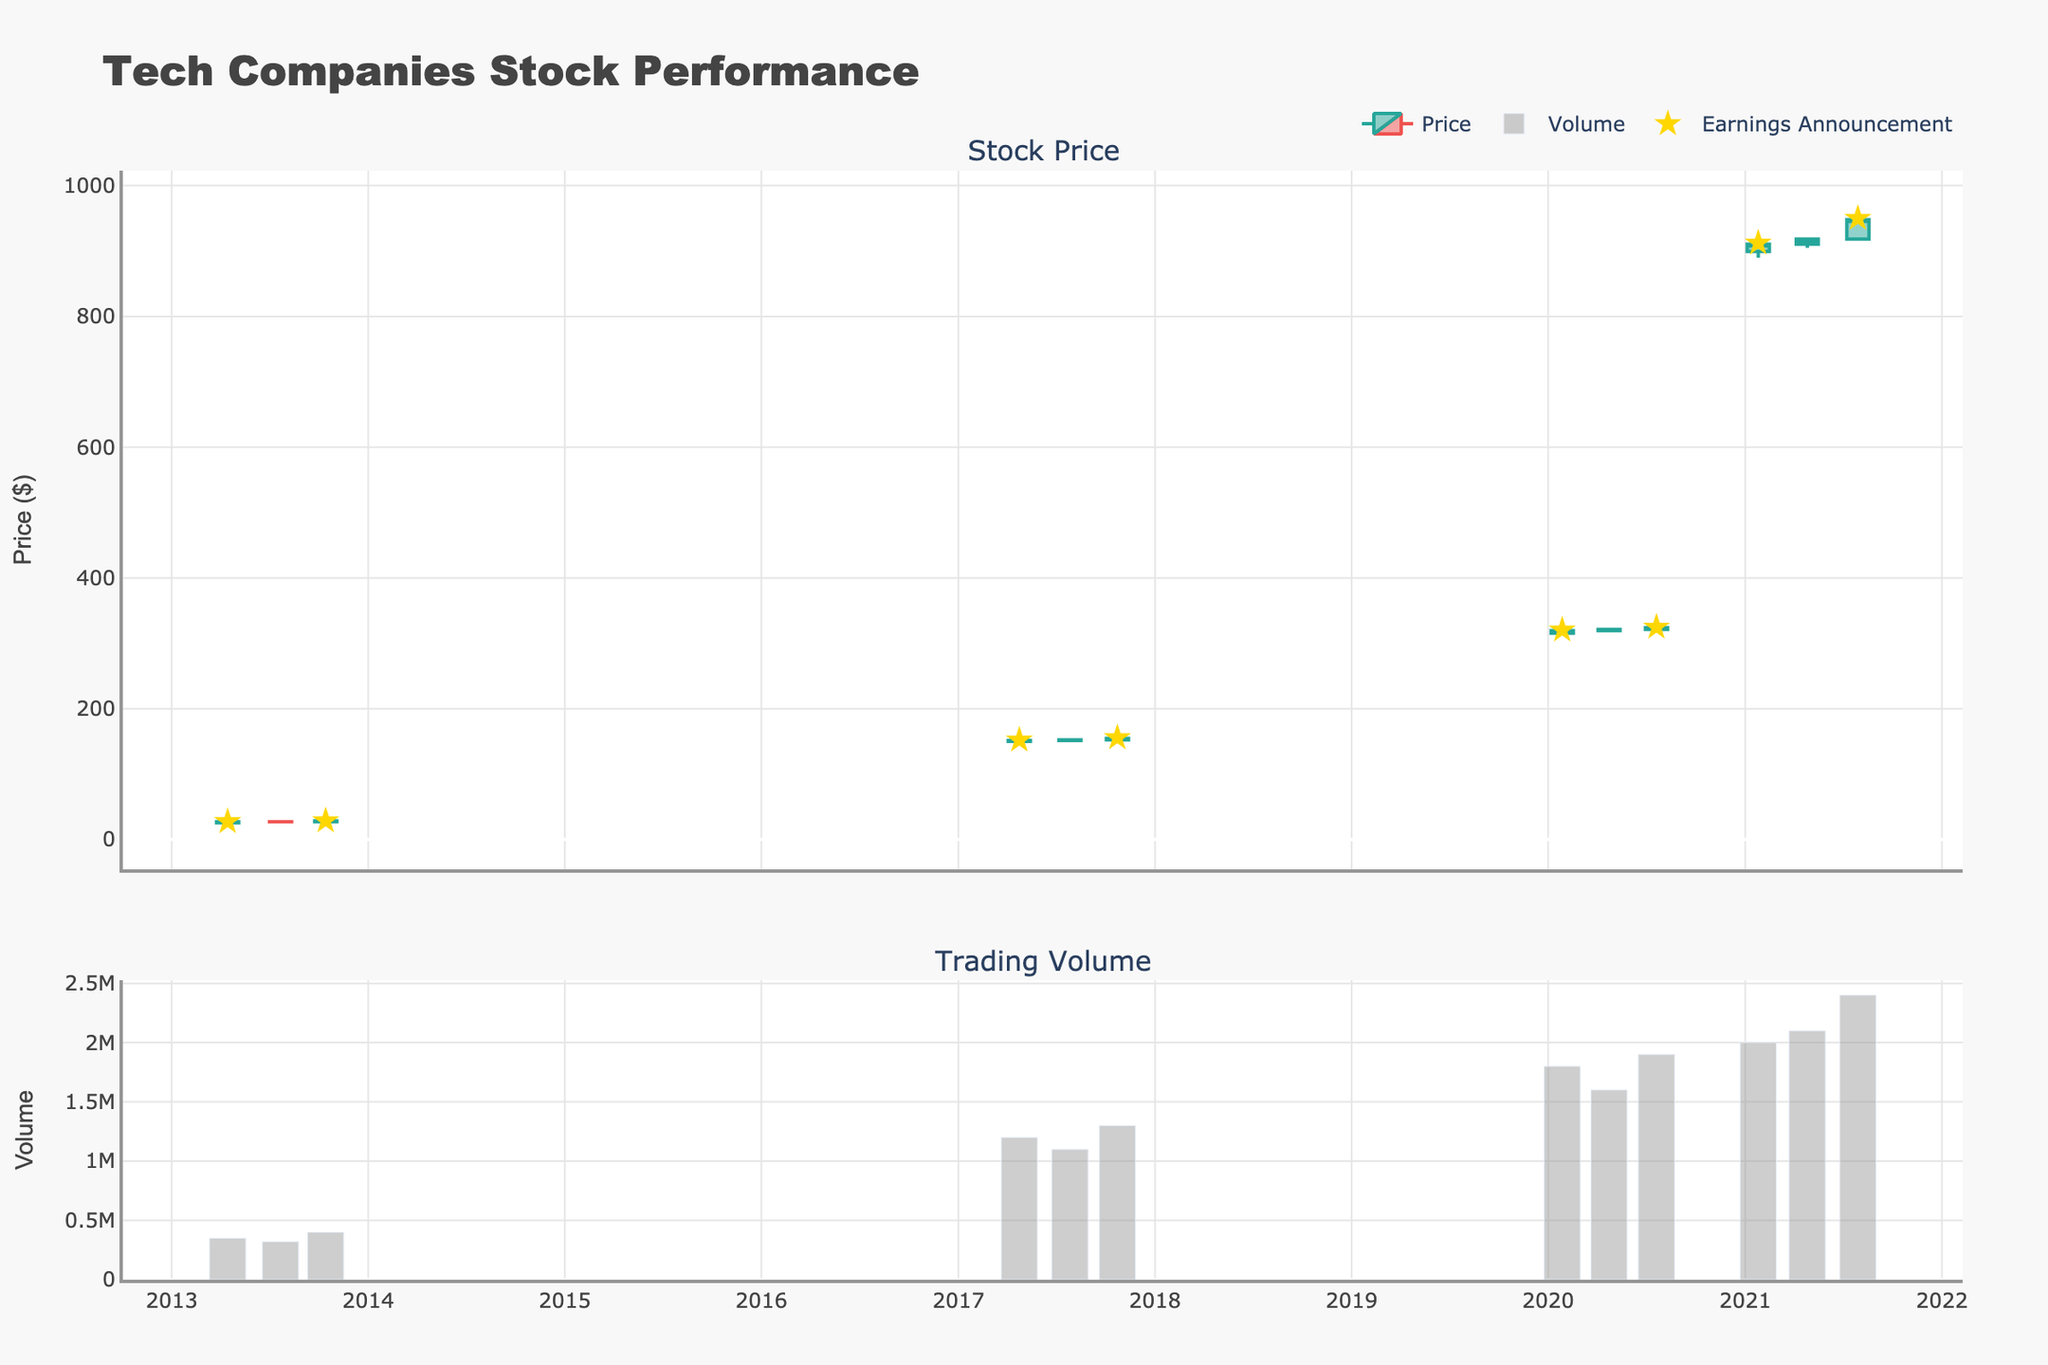What is the title of the plot? The title of the plot can be found at the top center of the figure. It typically summarizes the contents of the graph.
Answer: Tech Companies Stock Performance How many days have an earnings announcement? To find this, count the markers representing earnings announcements (stars) along the date axis in the stock price section of the plot.
Answer: 7 Which company's stock had the highest trading volume on a nonspecific earnings announcement day? Identify the bars in the Volume chart that do not correspond to earnings announcement markers (stars) and find the one with the greatest value.
Answer: Amazon What is the price range of Google's stock on October 23, 2017? Locate the candlestick for the date October 23, 2017, then check the High and Low prices listed for that day.
Answer: 151.20 to 155.65 Did Apple’s stock price increase or decrease after the earnings announcement on April 15, 2013? Look at the candlestick for April 15, 2013, and compare the Open price to the Close price to see if it increased or decreased.
Answer: Increase Which company showed the greatest price increase after an earnings announcement based on the candlestick chart? Compare the difference between Open and Close prices on all earnings announcement dates, then find the largest increase.
Answer: Amazon on July 29, 2021 What is the average trading volume across all recorded dates? Find the total sum of the trading volumes and divide by the number of recorded dates.
Answer: 1,275,000 How did the volume of trading change after Microsoft's earnings announcement on January 27, 2020? Compare the trading volume on January 27, 2020, with the volume on the next recorded date, April 23, 2020, and determine the difference.
Answer: Decreased by 200,000 Which two companies had stock price increases after earnings announcements in 2020? Check the candlestick data for dates in 2020 with earnings announcements and verify increases in stock prices by comparing Open and Close prices.
Answer: Microsoft On which date did Apple have an earnings announcement but the stock price did not show significant movement? Find the date corresponding to the earnings announcement for Apple where the Open and Close prices are nearly the same or very close.
Answer: July 22, 2013 